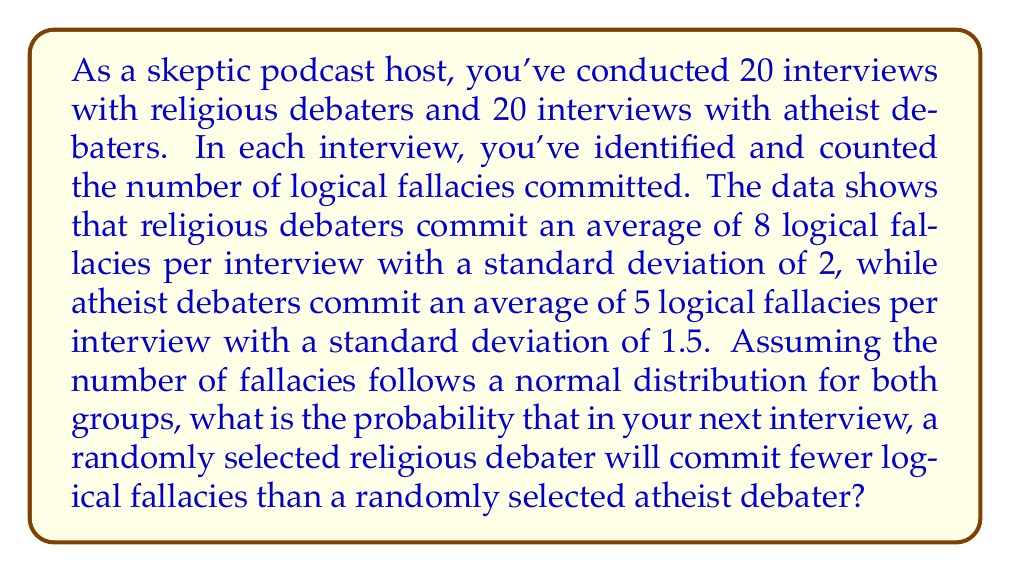Help me with this question. To solve this problem, we need to follow these steps:

1) First, we need to define our variables:
   Let $R$ be the number of fallacies committed by a religious debater
   Let $A$ be the number of fallacies committed by an atheist debater

2) We're given:
   $R \sim N(\mu_R = 8, \sigma_R = 2)$
   $A \sim N(\mu_A = 5, \sigma_A = 1.5)$

3) We want to find $P(R < A)$

4) This is equivalent to finding $P(R - A < 0)$

5) The difference of two normally distributed variables is also normally distributed:
   $R - A \sim N(\mu_{R-A}, \sigma_{R-A})$

   Where:
   $\mu_{R-A} = \mu_R - \mu_A = 8 - 5 = 3$
   $\sigma_{R-A} = \sqrt{\sigma_R^2 + \sigma_A^2} = \sqrt{2^2 + 1.5^2} = \sqrt{6.25} = 2.5$

6) So, $R - A \sim N(3, 2.5)$

7) We need to find $P(R - A < 0)$, which is equivalent to finding the z-score of 0:

   $z = \frac{x - \mu}{\sigma} = \frac{0 - 3}{2.5} = -1.2$

8) Using a standard normal distribution table or calculator, we can find:
   $P(Z < -1.2) \approx 0.1151$

Therefore, the probability that a randomly selected religious debater will commit fewer logical fallacies than a randomly selected atheist debater is approximately 0.1151 or 11.51%.
Answer: 0.1151 or 11.51% 